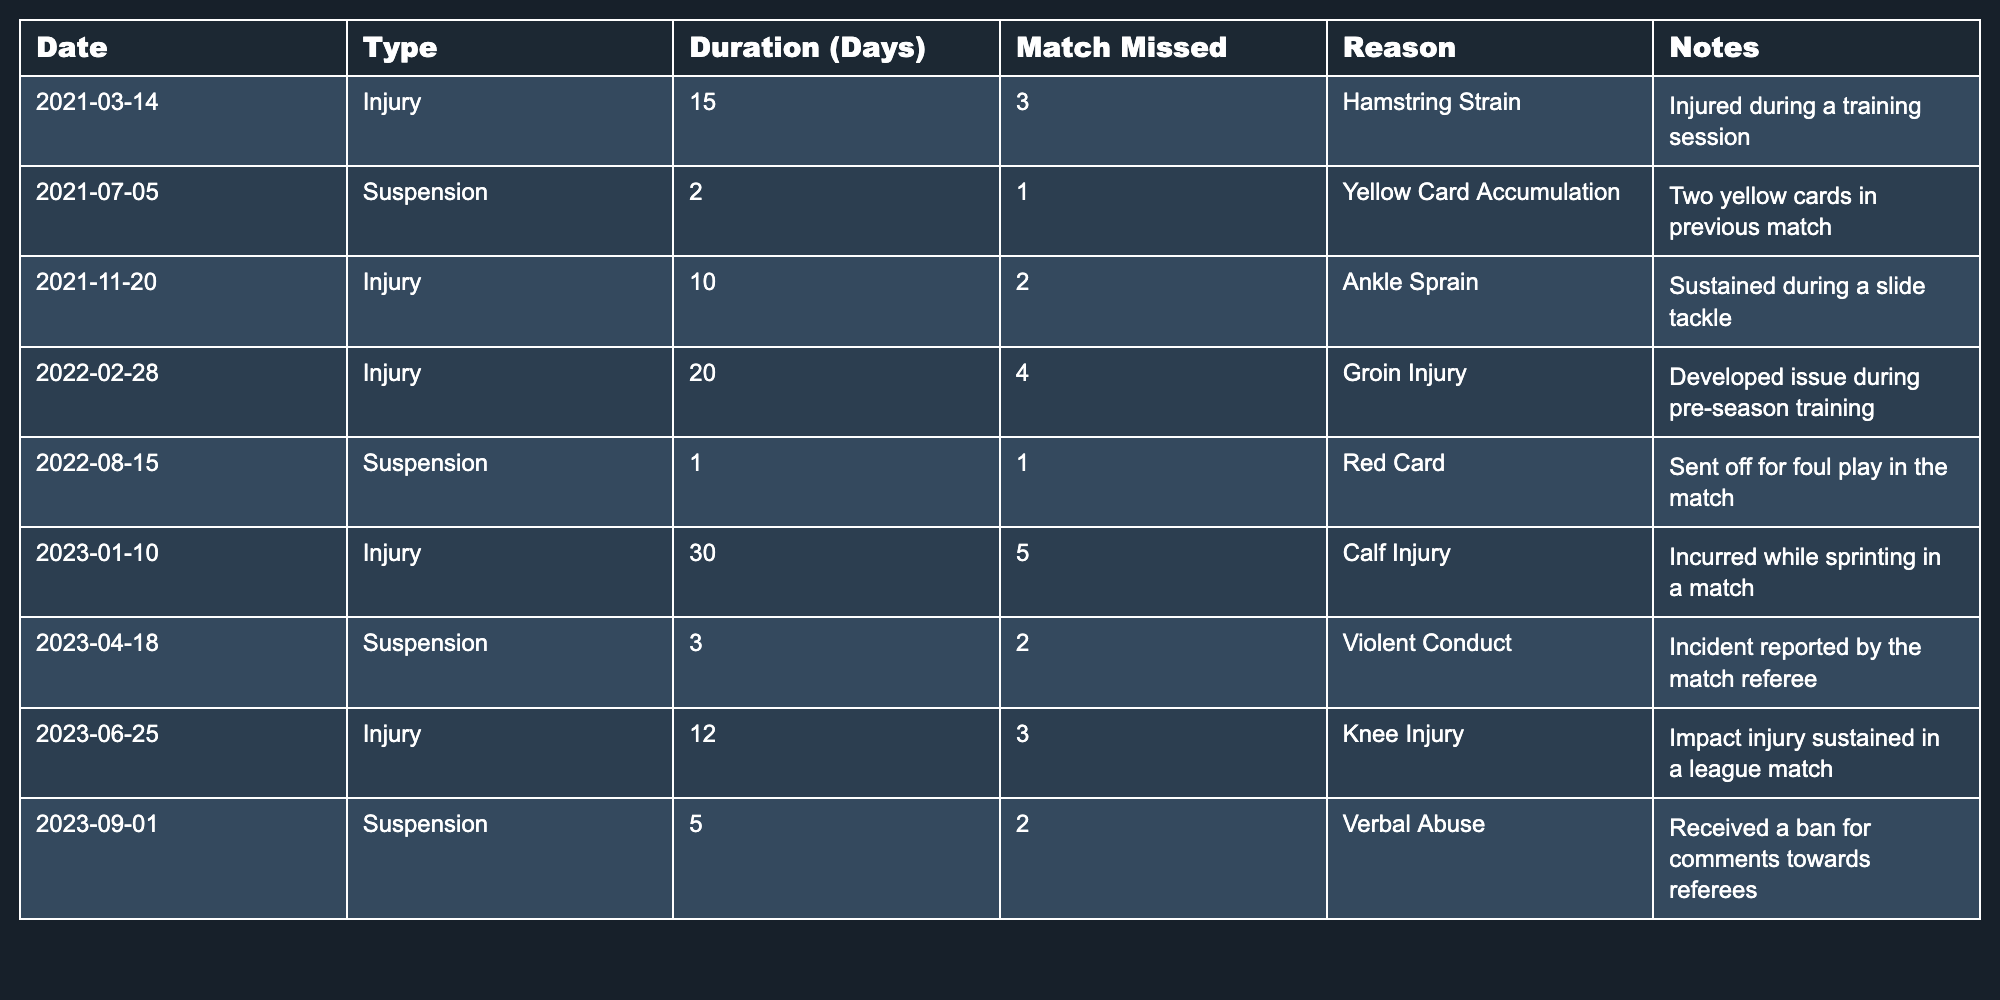What was the longest duration of injury for Tití Rodríguez? The table shows multiple instances of injury, with the maximum duration being 30 days for a calf injury on January 10, 2023.
Answer: 30 days How many matches did Tití miss due to injuries in 2022? Referring to the entries for injuries in 2022, there were two records: 4 matches missed for the groin injury and 2 matches for the ankle sprain, summing to 6 matches.
Answer: 6 matches Did Tití Rodríguez receive a suspension for verbal abuse? Yes, the table shows a suspension for 5 days due to verbal abuse, received on September 1, 2023.
Answer: Yes What is the total number of matches missed due to suspensions? The suspensions are for 1 match on July 5, 2021, 1 match on August 15, 2022, 2 matches on April 18, 2023, and 2 matches on September 1, 2023, which totals 6 missed matches.
Answer: 6 matches What was the average duration of injuries faced by Tití Rodríguez? To find the average, add all the durations of injuries (15, 10, 20, 30, 12), which totals 87 days, and divide by the number of injury instances (5), resulting in an average of 17.4 days.
Answer: 17.4 days In which month did Tití Rodriguez have the highest number of days missed due to injury? Analyzing the durations, the longest was 30 days for the calf injury in January 2023. This is more than any other injury duration listed.
Answer: January Was there any instance of Tití Rodríguez's injury resulting from a training session? Yes, the hamstring strain on March 14, 2021, occurred during a training session, as noted in the 'Reason' column.
Answer: Yes How many total injuries and suspensions did Tití Rodríguez experience during 2021? In 2021, there were 2 injuries (hamstring strain and ankle sprain) and 1 suspension (for yellow card accumulation), totaling 3 incidents.
Answer: 3 incidents What kind of injury caused Tití to miss 5 matches in January 2023? The entry for January 10, 2023, indicates that a calf injury led to missing 5 matches.
Answer: Calf injury Did Tití Rodríguez experience any red card suspensions? Yes, one incident on August 15, 2022, is recorded as a red card suspension.
Answer: Yes 